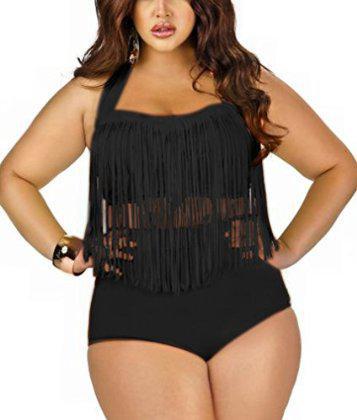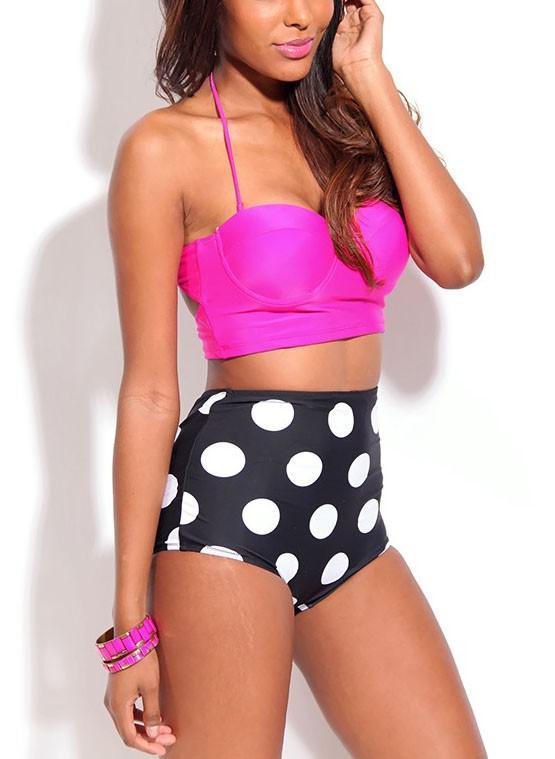The first image is the image on the left, the second image is the image on the right. Considering the images on both sides, is "One of the models is wearing sunglasses." valid? Answer yes or no. No. 